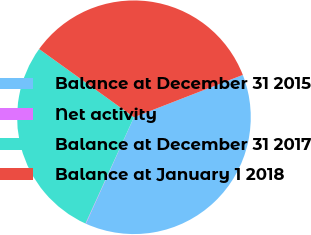Convert chart to OTSL. <chart><loc_0><loc_0><loc_500><loc_500><pie_chart><fcel>Balance at December 31 2015<fcel>Net activity<fcel>Balance at December 31 2017<fcel>Balance at January 1 2018<nl><fcel>37.65%<fcel>0.06%<fcel>28.12%<fcel>34.17%<nl></chart> 